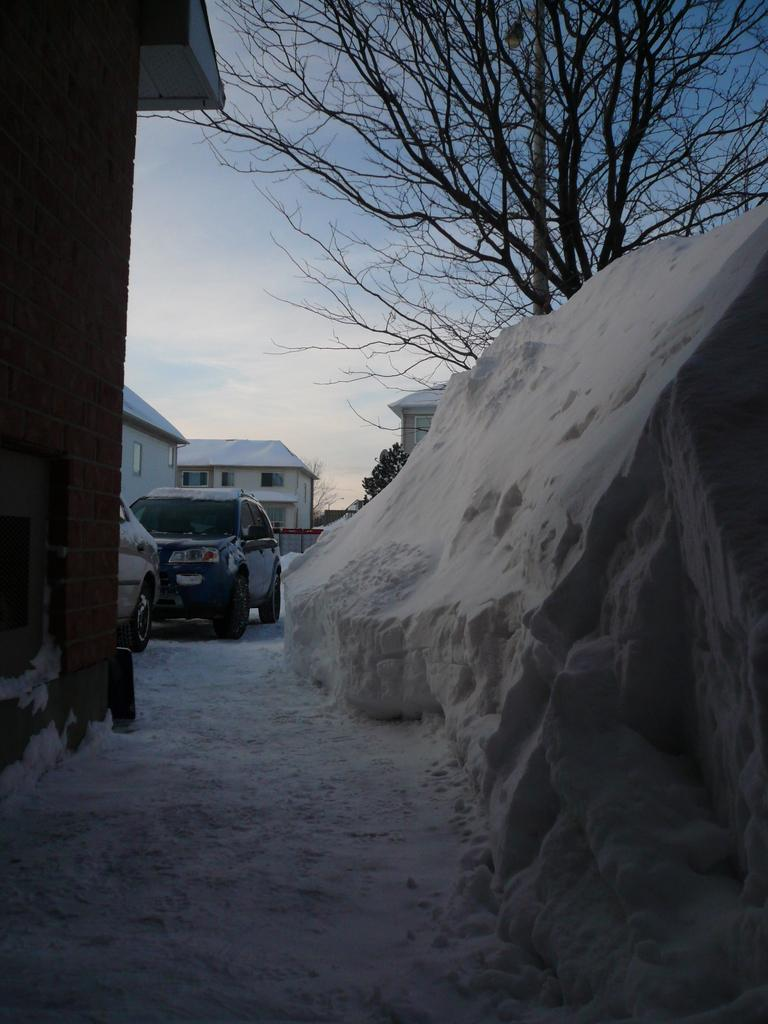What type of weather is depicted in the image? There is snow in the image, indicating a winter scene. What type of vehicles can be seen in the image? There are cars in the image. What type of buildings are present in the image? There are houses in the image. What type of vegetation is present in the image? There are trees in the image. What is visible in the sky in the image? The sky is visible in the image, and clouds are present. What causes the spark to occur in the image? There is no spark present in the image; it is a winter scene with snow, cars, houses, trees, and a cloudy sky. 